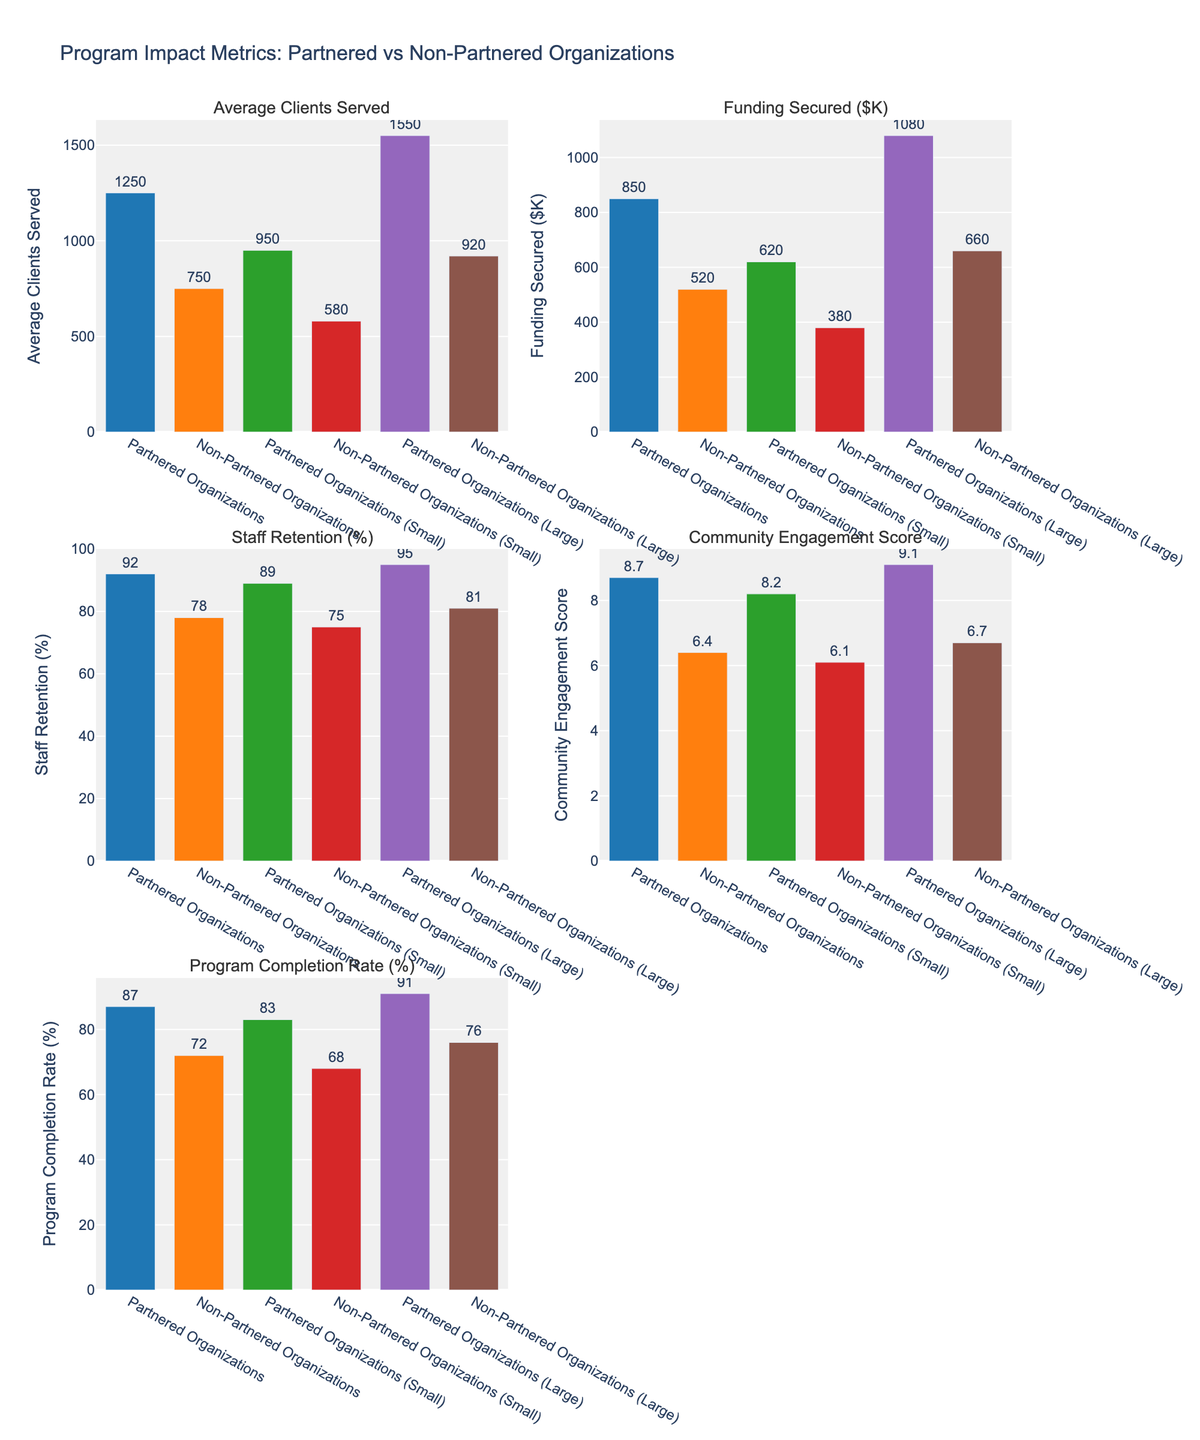Which type of organization serves the most clients on average? The bar representing "Average Clients Served" for "Partnered Organizations (Large)" is the highest among all, indicating they serve the most clients on average.
Answer: Partnered Organizations (Large) How much more funding do partnered organizations secure compared to non-partnered organizations? Look at the "Funding Secured ($K)" section. Partnered Organizations secure $850K while Non-Partnered Organizations secure $520K. Subtract the latter from the former: $850K - $520K = $330K.
Answer: $330K What is the difference in staff retention between partnered and non-partnered large organizations? The "Staff Retention (%)" for Partnered Organizations (Large) is 95%, and for Non-Partnered Organizations (Large), it is 81%. Subtract 81 from 95: 95% - 81% = 14%.
Answer: 14% Which category of organizations has the highest community engagement score? The "Community Engagement Score" for "Partnered Organizations (Large)" is the highest, with a score of 9.1.
Answer: Partnered Organizations (Large) Are partnered organizations (small) more effective in program completion than non-partnered organizations (small)? Compare the "Program Completion Rate (%)" for both: Partnered Organizations (Small) have 83%, while Non-Partnered Organizations (Small) have 68%. Partnered Organizations (Small) have a higher rate.
Answer: Yes What is the percentage increase in program completion rate from non-partnered to partnered large organizations? The "Program Completion Rate (%)" for Non-Partnered Organizations (Large) is 76%, and for Partnered Organizations (Large), it is 91%. Calculate the percentage increase: ((91 - 76) / 76) * 100 ≈ 19.74%.
Answer: 19.74% Which type of organization has the lowest funding secured, and what is the amount? The bar for "Funding Secured ($K)" reveals that "Non-Partnered Organizations (Small)" have the lowest amount at $380K.
Answer: Non-Partnered Organizations (Small), $380K How does the average staff retention of all partnered organizations compare to the average of non-partnered organizations? Calculate the average staff retention for both: Partnered (92%, 89%, 95%) averages to (92 + 89 + 95) / 3 = 92%. Non-partnered (78%, 75%, 81%) averages to (78 + 75 + 81) / 3 ≈ 78%. Partnered organizations have a higher average staff retention.
Answer: Higher By how much does community engagement score differ between partnered and non-partnered organizations overall? The average "Community Engagement Score" for partnered (8.7, 8.2, 9.1) is (8.7 + 8.2 + 9.1) / 3 ≈ 8.67. For non-partnered (6.4, 6.1, 6.7), it is (6.4 + 6.1 + 6.7) / 3 ≈ 6.4. The difference is 8.67 - 6.4 ≈ 2.27.
Answer: 2.27 